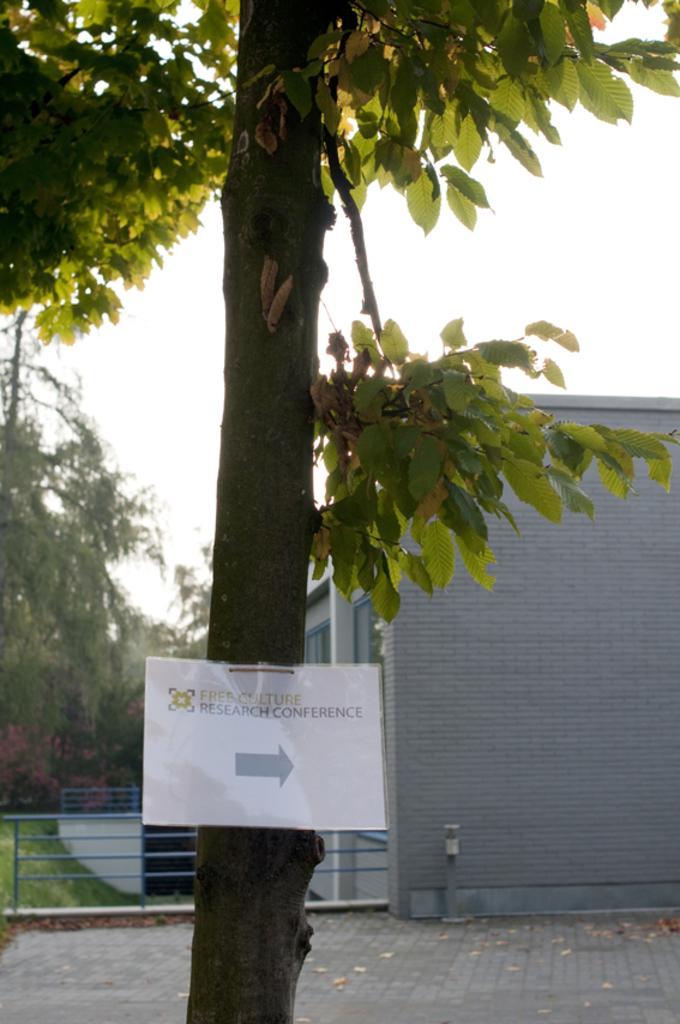Please provide a concise description of this image. In this picture in the middle, we can also see a tree, on that tree, we can see a white color board. On the right side, we can see a building and a pole. On the left side there are some trees, metal grills. On the top, we can see a sky, at the bottom there is a land. 